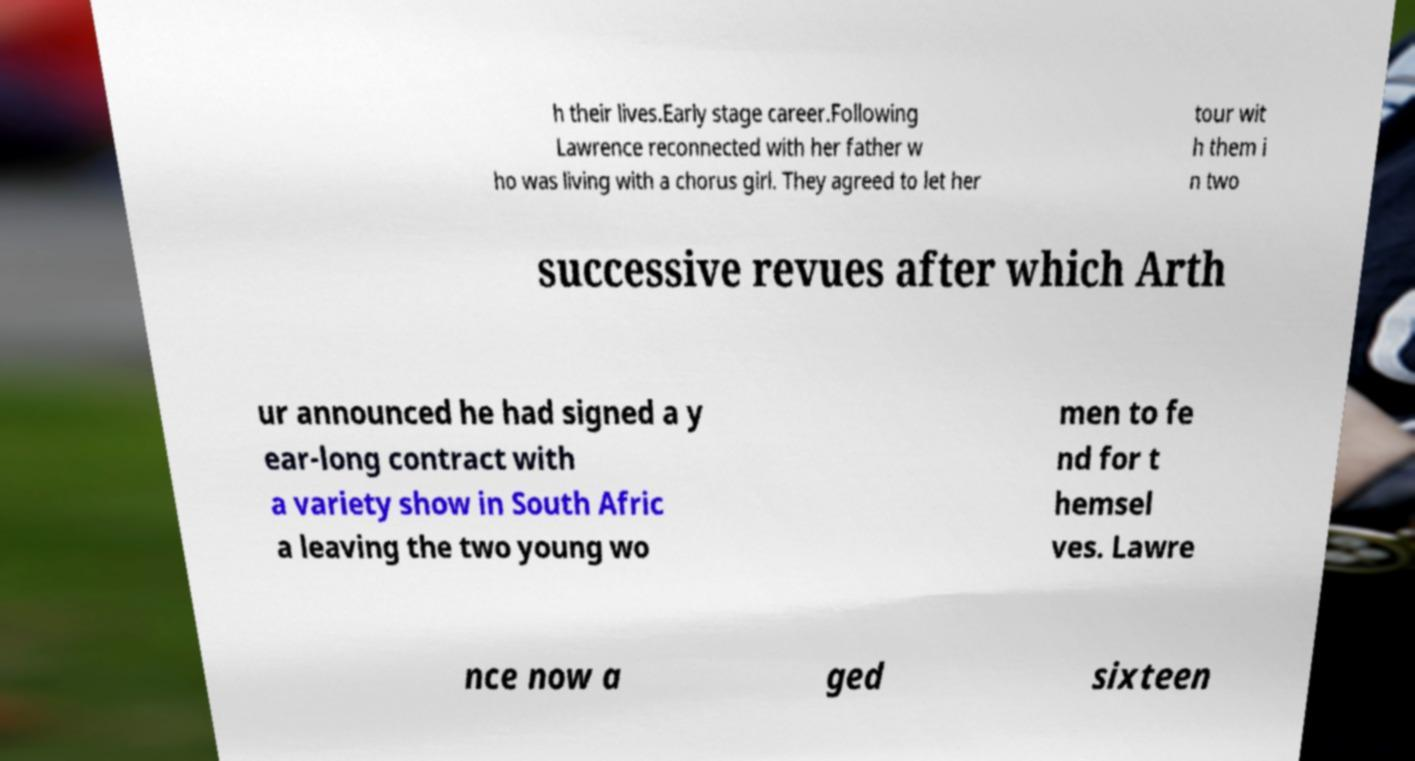I need the written content from this picture converted into text. Can you do that? h their lives.Early stage career.Following Lawrence reconnected with her father w ho was living with a chorus girl. They agreed to let her tour wit h them i n two successive revues after which Arth ur announced he had signed a y ear-long contract with a variety show in South Afric a leaving the two young wo men to fe nd for t hemsel ves. Lawre nce now a ged sixteen 